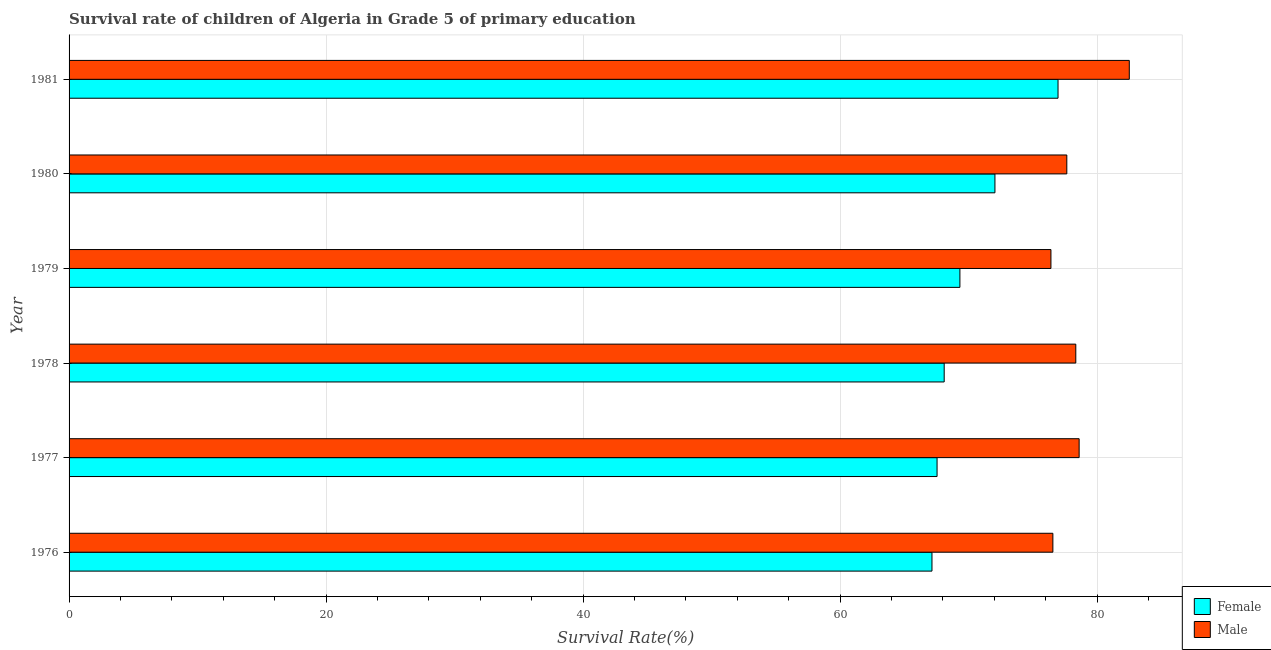How many different coloured bars are there?
Keep it short and to the point. 2. Are the number of bars per tick equal to the number of legend labels?
Give a very brief answer. Yes. Are the number of bars on each tick of the Y-axis equal?
Offer a terse response. Yes. How many bars are there on the 3rd tick from the top?
Your response must be concise. 2. What is the label of the 5th group of bars from the top?
Give a very brief answer. 1977. What is the survival rate of male students in primary education in 1979?
Make the answer very short. 76.41. Across all years, what is the maximum survival rate of female students in primary education?
Provide a succinct answer. 76.96. Across all years, what is the minimum survival rate of male students in primary education?
Your answer should be very brief. 76.41. In which year was the survival rate of male students in primary education maximum?
Your answer should be very brief. 1981. In which year was the survival rate of male students in primary education minimum?
Provide a succinct answer. 1979. What is the total survival rate of female students in primary education in the graph?
Provide a succinct answer. 421.13. What is the difference between the survival rate of male students in primary education in 1976 and that in 1980?
Provide a short and direct response. -1.08. What is the difference between the survival rate of male students in primary education in 1981 and the survival rate of female students in primary education in 1980?
Offer a very short reply. 10.46. What is the average survival rate of female students in primary education per year?
Offer a very short reply. 70.19. In the year 1976, what is the difference between the survival rate of male students in primary education and survival rate of female students in primary education?
Give a very brief answer. 9.41. Is the difference between the survival rate of male students in primary education in 1976 and 1980 greater than the difference between the survival rate of female students in primary education in 1976 and 1980?
Offer a terse response. Yes. What is the difference between the highest and the second highest survival rate of female students in primary education?
Give a very brief answer. 4.91. What is the difference between the highest and the lowest survival rate of female students in primary education?
Your response must be concise. 9.81. Is the sum of the survival rate of male students in primary education in 1977 and 1981 greater than the maximum survival rate of female students in primary education across all years?
Ensure brevity in your answer.  Yes. What does the 2nd bar from the top in 1976 represents?
Make the answer very short. Female. How many bars are there?
Ensure brevity in your answer.  12. How many years are there in the graph?
Your answer should be very brief. 6. Does the graph contain any zero values?
Make the answer very short. No. How many legend labels are there?
Keep it short and to the point. 2. What is the title of the graph?
Provide a succinct answer. Survival rate of children of Algeria in Grade 5 of primary education. Does "Investment in Telecom" appear as one of the legend labels in the graph?
Your response must be concise. No. What is the label or title of the X-axis?
Provide a succinct answer. Survival Rate(%). What is the label or title of the Y-axis?
Offer a very short reply. Year. What is the Survival Rate(%) in Female in 1976?
Offer a terse response. 67.15. What is the Survival Rate(%) in Male in 1976?
Keep it short and to the point. 76.56. What is the Survival Rate(%) of Female in 1977?
Offer a terse response. 67.55. What is the Survival Rate(%) in Male in 1977?
Provide a short and direct response. 78.6. What is the Survival Rate(%) of Female in 1978?
Provide a short and direct response. 68.1. What is the Survival Rate(%) of Male in 1978?
Ensure brevity in your answer.  78.34. What is the Survival Rate(%) in Female in 1979?
Offer a terse response. 69.32. What is the Survival Rate(%) of Male in 1979?
Keep it short and to the point. 76.41. What is the Survival Rate(%) of Female in 1980?
Ensure brevity in your answer.  72.05. What is the Survival Rate(%) in Male in 1980?
Give a very brief answer. 77.64. What is the Survival Rate(%) of Female in 1981?
Give a very brief answer. 76.96. What is the Survival Rate(%) of Male in 1981?
Offer a terse response. 82.51. Across all years, what is the maximum Survival Rate(%) in Female?
Your answer should be compact. 76.96. Across all years, what is the maximum Survival Rate(%) in Male?
Your response must be concise. 82.51. Across all years, what is the minimum Survival Rate(%) in Female?
Offer a terse response. 67.15. Across all years, what is the minimum Survival Rate(%) in Male?
Give a very brief answer. 76.41. What is the total Survival Rate(%) of Female in the graph?
Keep it short and to the point. 421.13. What is the total Survival Rate(%) in Male in the graph?
Offer a terse response. 470.06. What is the difference between the Survival Rate(%) of Female in 1976 and that in 1977?
Your response must be concise. -0.4. What is the difference between the Survival Rate(%) of Male in 1976 and that in 1977?
Your answer should be compact. -2.04. What is the difference between the Survival Rate(%) of Female in 1976 and that in 1978?
Offer a very short reply. -0.95. What is the difference between the Survival Rate(%) in Male in 1976 and that in 1978?
Your answer should be very brief. -1.78. What is the difference between the Survival Rate(%) of Female in 1976 and that in 1979?
Make the answer very short. -2.17. What is the difference between the Survival Rate(%) in Male in 1976 and that in 1979?
Ensure brevity in your answer.  0.15. What is the difference between the Survival Rate(%) in Female in 1976 and that in 1980?
Offer a very short reply. -4.9. What is the difference between the Survival Rate(%) in Male in 1976 and that in 1980?
Give a very brief answer. -1.09. What is the difference between the Survival Rate(%) in Female in 1976 and that in 1981?
Provide a succinct answer. -9.81. What is the difference between the Survival Rate(%) of Male in 1976 and that in 1981?
Your response must be concise. -5.95. What is the difference between the Survival Rate(%) of Female in 1977 and that in 1978?
Your answer should be compact. -0.55. What is the difference between the Survival Rate(%) in Male in 1977 and that in 1978?
Offer a very short reply. 0.26. What is the difference between the Survival Rate(%) of Female in 1977 and that in 1979?
Your response must be concise. -1.78. What is the difference between the Survival Rate(%) in Male in 1977 and that in 1979?
Offer a very short reply. 2.2. What is the difference between the Survival Rate(%) in Female in 1977 and that in 1980?
Ensure brevity in your answer.  -4.5. What is the difference between the Survival Rate(%) in Male in 1977 and that in 1980?
Give a very brief answer. 0.96. What is the difference between the Survival Rate(%) in Female in 1977 and that in 1981?
Offer a terse response. -9.41. What is the difference between the Survival Rate(%) in Male in 1977 and that in 1981?
Your response must be concise. -3.9. What is the difference between the Survival Rate(%) of Female in 1978 and that in 1979?
Keep it short and to the point. -1.22. What is the difference between the Survival Rate(%) in Male in 1978 and that in 1979?
Offer a terse response. 1.94. What is the difference between the Survival Rate(%) of Female in 1978 and that in 1980?
Your answer should be compact. -3.95. What is the difference between the Survival Rate(%) in Male in 1978 and that in 1980?
Give a very brief answer. 0.7. What is the difference between the Survival Rate(%) of Female in 1978 and that in 1981?
Ensure brevity in your answer.  -8.86. What is the difference between the Survival Rate(%) of Male in 1978 and that in 1981?
Give a very brief answer. -4.16. What is the difference between the Survival Rate(%) in Female in 1979 and that in 1980?
Keep it short and to the point. -2.73. What is the difference between the Survival Rate(%) of Male in 1979 and that in 1980?
Provide a short and direct response. -1.24. What is the difference between the Survival Rate(%) in Female in 1979 and that in 1981?
Your response must be concise. -7.63. What is the difference between the Survival Rate(%) of Male in 1979 and that in 1981?
Ensure brevity in your answer.  -6.1. What is the difference between the Survival Rate(%) in Female in 1980 and that in 1981?
Offer a terse response. -4.91. What is the difference between the Survival Rate(%) of Male in 1980 and that in 1981?
Your answer should be very brief. -4.86. What is the difference between the Survival Rate(%) of Female in 1976 and the Survival Rate(%) of Male in 1977?
Provide a succinct answer. -11.45. What is the difference between the Survival Rate(%) in Female in 1976 and the Survival Rate(%) in Male in 1978?
Provide a short and direct response. -11.19. What is the difference between the Survival Rate(%) in Female in 1976 and the Survival Rate(%) in Male in 1979?
Your response must be concise. -9.26. What is the difference between the Survival Rate(%) in Female in 1976 and the Survival Rate(%) in Male in 1980?
Offer a terse response. -10.49. What is the difference between the Survival Rate(%) in Female in 1976 and the Survival Rate(%) in Male in 1981?
Ensure brevity in your answer.  -15.36. What is the difference between the Survival Rate(%) of Female in 1977 and the Survival Rate(%) of Male in 1978?
Provide a short and direct response. -10.8. What is the difference between the Survival Rate(%) in Female in 1977 and the Survival Rate(%) in Male in 1979?
Your response must be concise. -8.86. What is the difference between the Survival Rate(%) in Female in 1977 and the Survival Rate(%) in Male in 1980?
Make the answer very short. -10.1. What is the difference between the Survival Rate(%) of Female in 1977 and the Survival Rate(%) of Male in 1981?
Provide a short and direct response. -14.96. What is the difference between the Survival Rate(%) in Female in 1978 and the Survival Rate(%) in Male in 1979?
Your response must be concise. -8.31. What is the difference between the Survival Rate(%) in Female in 1978 and the Survival Rate(%) in Male in 1980?
Make the answer very short. -9.54. What is the difference between the Survival Rate(%) in Female in 1978 and the Survival Rate(%) in Male in 1981?
Offer a very short reply. -14.4. What is the difference between the Survival Rate(%) of Female in 1979 and the Survival Rate(%) of Male in 1980?
Offer a very short reply. -8.32. What is the difference between the Survival Rate(%) in Female in 1979 and the Survival Rate(%) in Male in 1981?
Your answer should be compact. -13.18. What is the difference between the Survival Rate(%) in Female in 1980 and the Survival Rate(%) in Male in 1981?
Provide a short and direct response. -10.46. What is the average Survival Rate(%) of Female per year?
Your answer should be very brief. 70.19. What is the average Survival Rate(%) of Male per year?
Ensure brevity in your answer.  78.34. In the year 1976, what is the difference between the Survival Rate(%) in Female and Survival Rate(%) in Male?
Give a very brief answer. -9.41. In the year 1977, what is the difference between the Survival Rate(%) in Female and Survival Rate(%) in Male?
Provide a short and direct response. -11.06. In the year 1978, what is the difference between the Survival Rate(%) in Female and Survival Rate(%) in Male?
Make the answer very short. -10.24. In the year 1979, what is the difference between the Survival Rate(%) of Female and Survival Rate(%) of Male?
Offer a very short reply. -7.08. In the year 1980, what is the difference between the Survival Rate(%) in Female and Survival Rate(%) in Male?
Your response must be concise. -5.59. In the year 1981, what is the difference between the Survival Rate(%) of Female and Survival Rate(%) of Male?
Keep it short and to the point. -5.55. What is the ratio of the Survival Rate(%) in Male in 1976 to that in 1977?
Your answer should be very brief. 0.97. What is the ratio of the Survival Rate(%) of Male in 1976 to that in 1978?
Offer a very short reply. 0.98. What is the ratio of the Survival Rate(%) of Female in 1976 to that in 1979?
Offer a very short reply. 0.97. What is the ratio of the Survival Rate(%) of Female in 1976 to that in 1980?
Provide a succinct answer. 0.93. What is the ratio of the Survival Rate(%) of Male in 1976 to that in 1980?
Offer a very short reply. 0.99. What is the ratio of the Survival Rate(%) in Female in 1976 to that in 1981?
Keep it short and to the point. 0.87. What is the ratio of the Survival Rate(%) in Male in 1976 to that in 1981?
Your answer should be compact. 0.93. What is the ratio of the Survival Rate(%) of Female in 1977 to that in 1978?
Keep it short and to the point. 0.99. What is the ratio of the Survival Rate(%) in Male in 1977 to that in 1978?
Ensure brevity in your answer.  1. What is the ratio of the Survival Rate(%) of Female in 1977 to that in 1979?
Ensure brevity in your answer.  0.97. What is the ratio of the Survival Rate(%) of Male in 1977 to that in 1979?
Your answer should be very brief. 1.03. What is the ratio of the Survival Rate(%) of Male in 1977 to that in 1980?
Your answer should be very brief. 1.01. What is the ratio of the Survival Rate(%) of Female in 1977 to that in 1981?
Keep it short and to the point. 0.88. What is the ratio of the Survival Rate(%) of Male in 1977 to that in 1981?
Provide a succinct answer. 0.95. What is the ratio of the Survival Rate(%) of Female in 1978 to that in 1979?
Offer a terse response. 0.98. What is the ratio of the Survival Rate(%) of Male in 1978 to that in 1979?
Offer a very short reply. 1.03. What is the ratio of the Survival Rate(%) of Female in 1978 to that in 1980?
Your answer should be very brief. 0.95. What is the ratio of the Survival Rate(%) of Male in 1978 to that in 1980?
Provide a short and direct response. 1.01. What is the ratio of the Survival Rate(%) in Female in 1978 to that in 1981?
Ensure brevity in your answer.  0.88. What is the ratio of the Survival Rate(%) of Male in 1978 to that in 1981?
Your answer should be compact. 0.95. What is the ratio of the Survival Rate(%) of Female in 1979 to that in 1980?
Give a very brief answer. 0.96. What is the ratio of the Survival Rate(%) of Male in 1979 to that in 1980?
Provide a succinct answer. 0.98. What is the ratio of the Survival Rate(%) in Female in 1979 to that in 1981?
Offer a very short reply. 0.9. What is the ratio of the Survival Rate(%) of Male in 1979 to that in 1981?
Keep it short and to the point. 0.93. What is the ratio of the Survival Rate(%) in Female in 1980 to that in 1981?
Give a very brief answer. 0.94. What is the ratio of the Survival Rate(%) of Male in 1980 to that in 1981?
Keep it short and to the point. 0.94. What is the difference between the highest and the second highest Survival Rate(%) in Female?
Offer a terse response. 4.91. What is the difference between the highest and the second highest Survival Rate(%) of Male?
Your response must be concise. 3.9. What is the difference between the highest and the lowest Survival Rate(%) of Female?
Your answer should be very brief. 9.81. What is the difference between the highest and the lowest Survival Rate(%) in Male?
Ensure brevity in your answer.  6.1. 